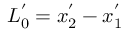Convert formula to latex. <formula><loc_0><loc_0><loc_500><loc_500>L _ { 0 } ^ { ^ { \prime } } = x _ { 2 } ^ { ^ { \prime } } - x _ { 1 } ^ { ^ { \prime } }</formula> 